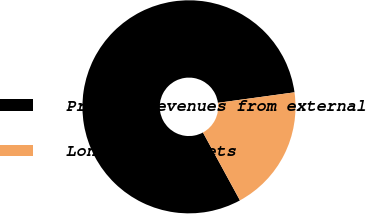Convert chart to OTSL. <chart><loc_0><loc_0><loc_500><loc_500><pie_chart><fcel>Product revenues from external<fcel>Long-lived assets<nl><fcel>80.77%<fcel>19.23%<nl></chart> 